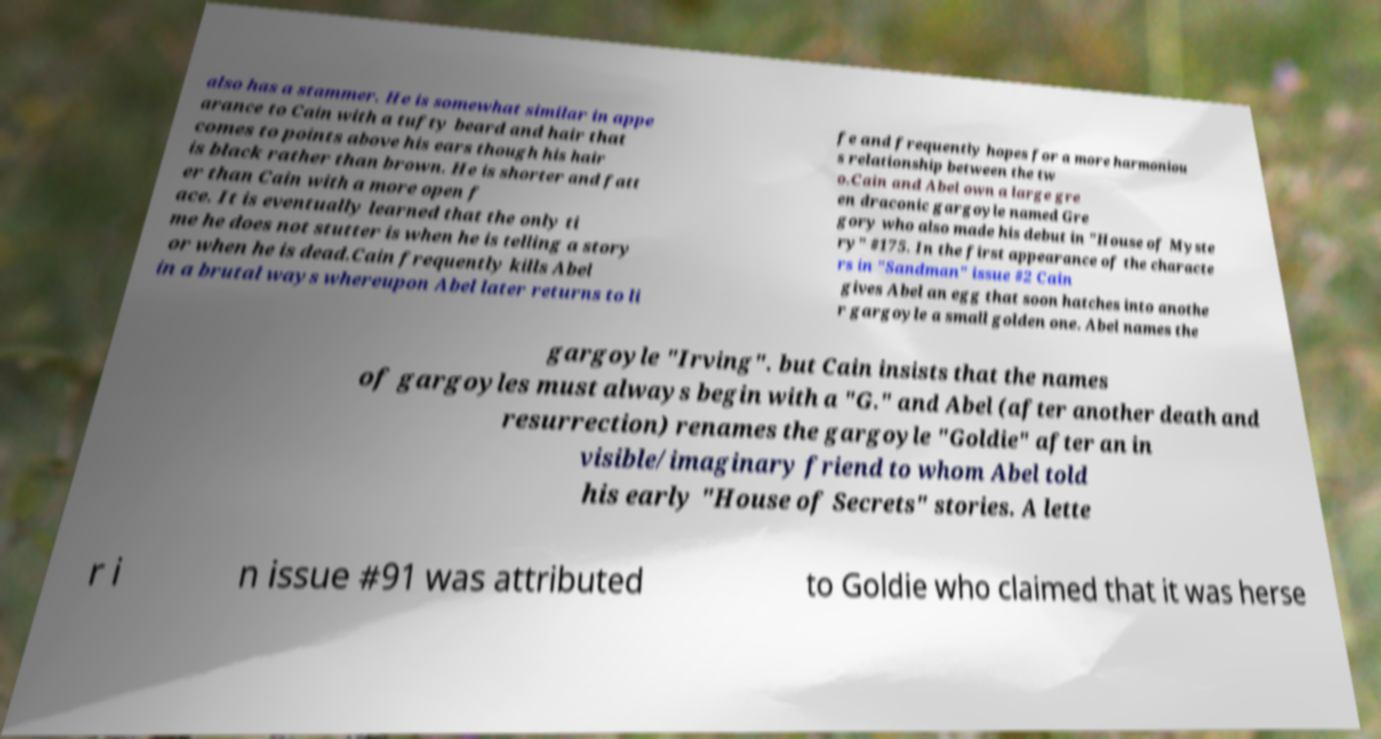Please identify and transcribe the text found in this image. also has a stammer. He is somewhat similar in appe arance to Cain with a tufty beard and hair that comes to points above his ears though his hair is black rather than brown. He is shorter and fatt er than Cain with a more open f ace. It is eventually learned that the only ti me he does not stutter is when he is telling a story or when he is dead.Cain frequently kills Abel in a brutal ways whereupon Abel later returns to li fe and frequently hopes for a more harmoniou s relationship between the tw o.Cain and Abel own a large gre en draconic gargoyle named Gre gory who also made his debut in "House of Myste ry" #175. In the first appearance of the characte rs in "Sandman" issue #2 Cain gives Abel an egg that soon hatches into anothe r gargoyle a small golden one. Abel names the gargoyle "Irving". but Cain insists that the names of gargoyles must always begin with a "G." and Abel (after another death and resurrection) renames the gargoyle "Goldie" after an in visible/imaginary friend to whom Abel told his early "House of Secrets" stories. A lette r i n issue #91 was attributed to Goldie who claimed that it was herse 